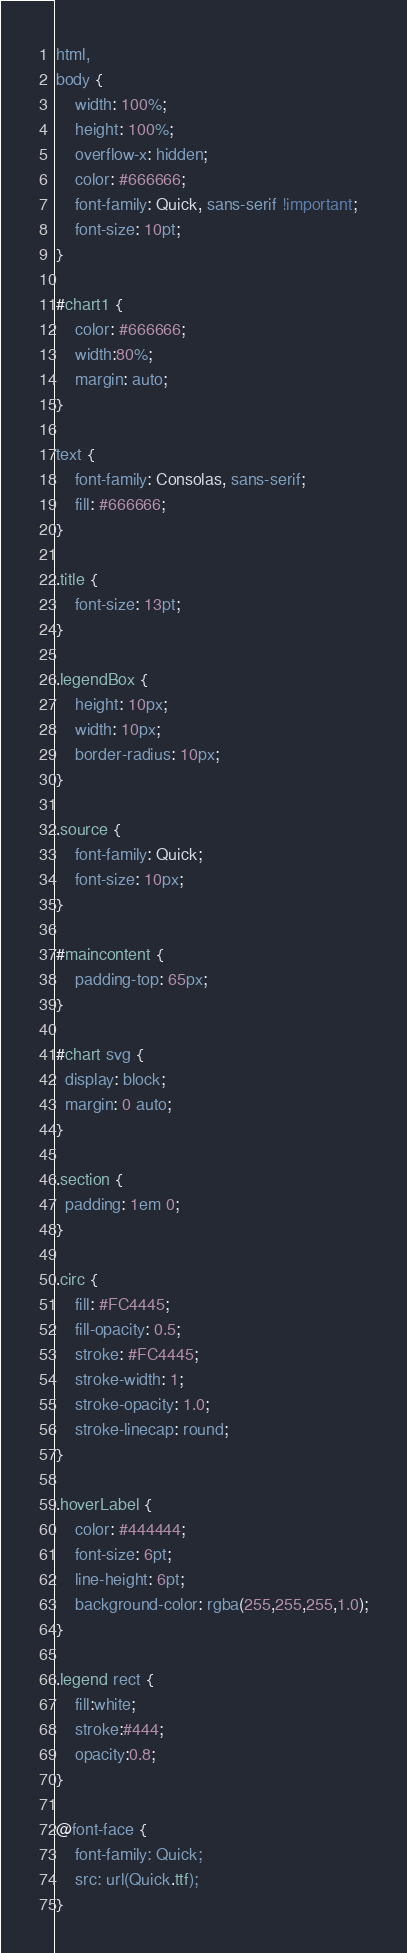<code> <loc_0><loc_0><loc_500><loc_500><_CSS_>html,
body {
    width: 100%;
    height: 100%;
    overflow-x: hidden;
    color: #666666;
    font-family: Quick, sans-serif !important;
    font-size: 10pt;
}

#chart1 {
    color: #666666;
    width:80%;
    margin: auto;
}

text {
    font-family: Consolas, sans-serif;
    fill: #666666;
}

.title {
    font-size: 13pt;
}

.legendBox {
    height: 10px;
    width: 10px;
    border-radius: 10px;
}

.source {
    font-family: Quick;
    font-size: 10px;
}

#maincontent {
    padding-top: 65px;
}

#chart svg {
  display: block;
  margin: 0 auto;
}

.section {
  padding: 1em 0;
}

.circ { 
    fill: #FC4445;
    fill-opacity: 0.5;
    stroke: #FC4445;
    stroke-width: 1;
    stroke-opacity: 1.0;
    stroke-linecap: round;
}

.hoverLabel {
    color: #444444;
    font-size: 6pt;
    line-height: 6pt;
    background-color: rgba(255,255,255,1.0);
}

.legend rect {
    fill:white;
    stroke:#444;
    opacity:0.8;
}

@font-face {
    font-family: Quick;
    src: url(Quick.ttf);
}</code> 